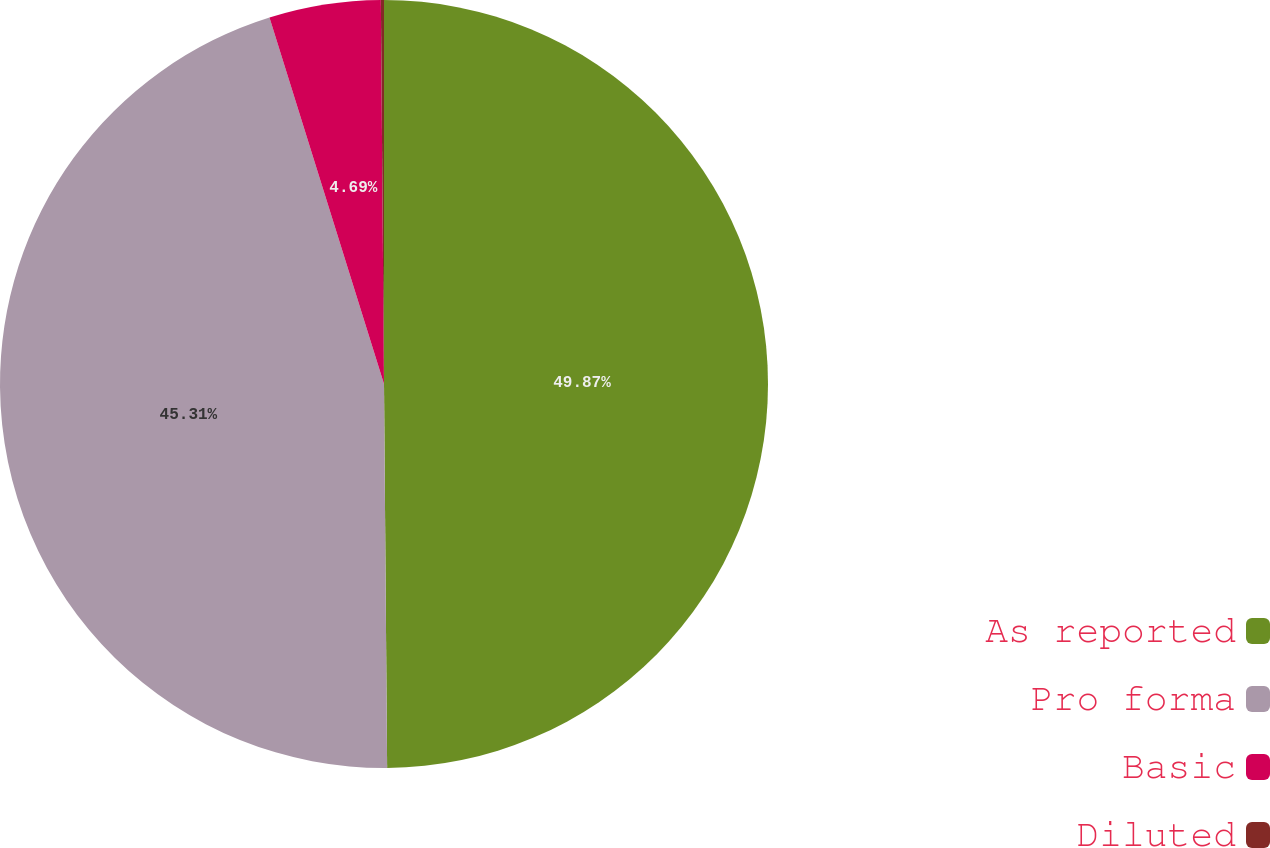Convert chart. <chart><loc_0><loc_0><loc_500><loc_500><pie_chart><fcel>As reported<fcel>Pro forma<fcel>Basic<fcel>Diluted<nl><fcel>49.87%<fcel>45.31%<fcel>4.69%<fcel>0.13%<nl></chart> 